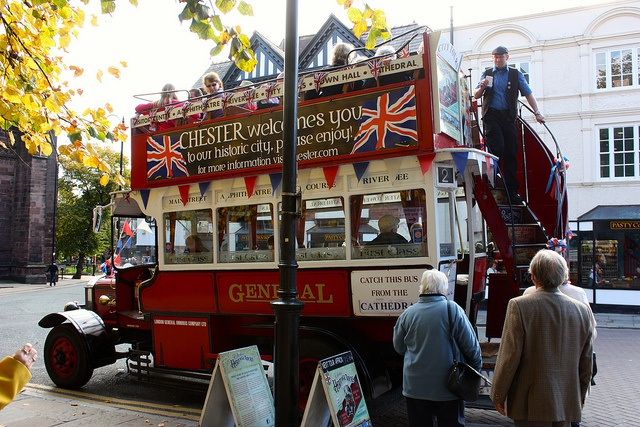Describe the objects in this image and their specific colors. I can see bus in khaki, black, maroon, darkgray, and gray tones, people in khaki, black, gray, and darkgray tones, people in khaki, black, blue, darkblue, and gray tones, people in khaki, black, navy, gray, and darkblue tones, and people in khaki, black, darkgray, maroon, and lightgray tones in this image. 